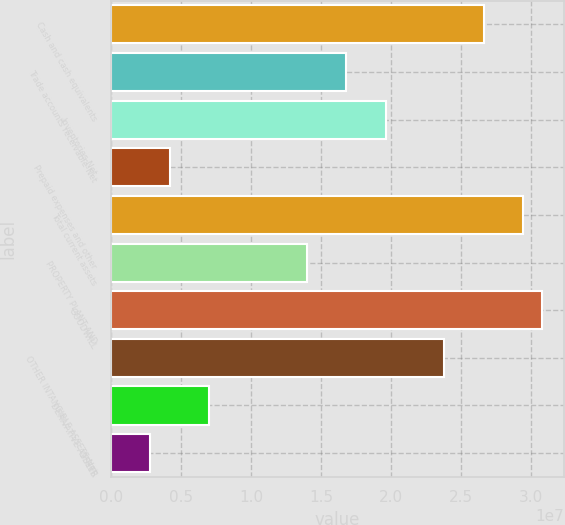Convert chart to OTSL. <chart><loc_0><loc_0><loc_500><loc_500><bar_chart><fcel>Cash and cash equivalents<fcel>Trade accounts receivable-Net<fcel>Inventories-Net<fcel>Prepaid expenses and other<fcel>Total current assets<fcel>PROPERTY PLANT AND<fcel>GOODWILL<fcel>OTHER INTANGIBLE ASSETS-Net<fcel>DERIVATIVE ASSETS<fcel>OTHER<nl><fcel>2.66108e+07<fcel>1.6807e+07<fcel>1.96081e+07<fcel>4.20218e+06<fcel>2.94118e+07<fcel>1.40059e+07<fcel>3.08124e+07<fcel>2.38097e+07<fcel>7.00325e+06<fcel>2.80164e+06<nl></chart> 